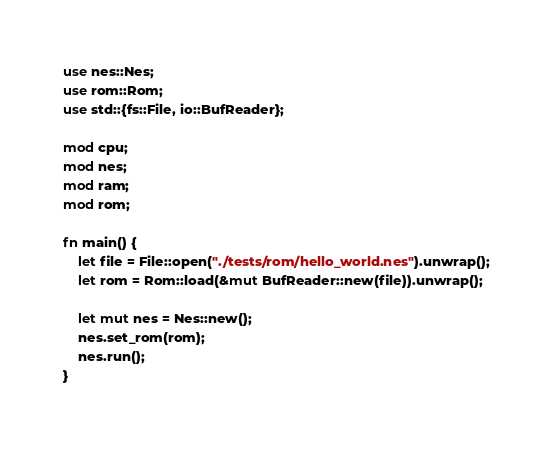Convert code to text. <code><loc_0><loc_0><loc_500><loc_500><_Rust_>use nes::Nes;
use rom::Rom;
use std::{fs::File, io::BufReader};

mod cpu;
mod nes;
mod ram;
mod rom;

fn main() {
    let file = File::open("./tests/rom/hello_world.nes").unwrap();
    let rom = Rom::load(&mut BufReader::new(file)).unwrap();

    let mut nes = Nes::new();
    nes.set_rom(rom);
    nes.run();
}
</code> 